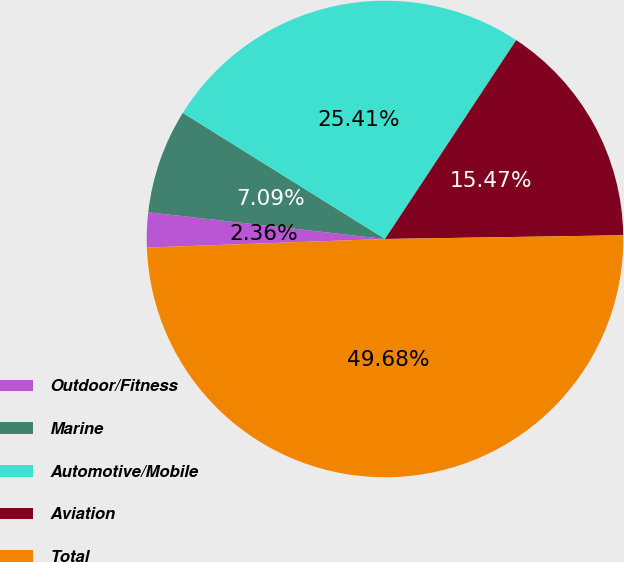Convert chart to OTSL. <chart><loc_0><loc_0><loc_500><loc_500><pie_chart><fcel>Outdoor/Fitness<fcel>Marine<fcel>Automotive/Mobile<fcel>Aviation<fcel>Total<nl><fcel>2.36%<fcel>7.09%<fcel>25.41%<fcel>15.47%<fcel>49.68%<nl></chart> 